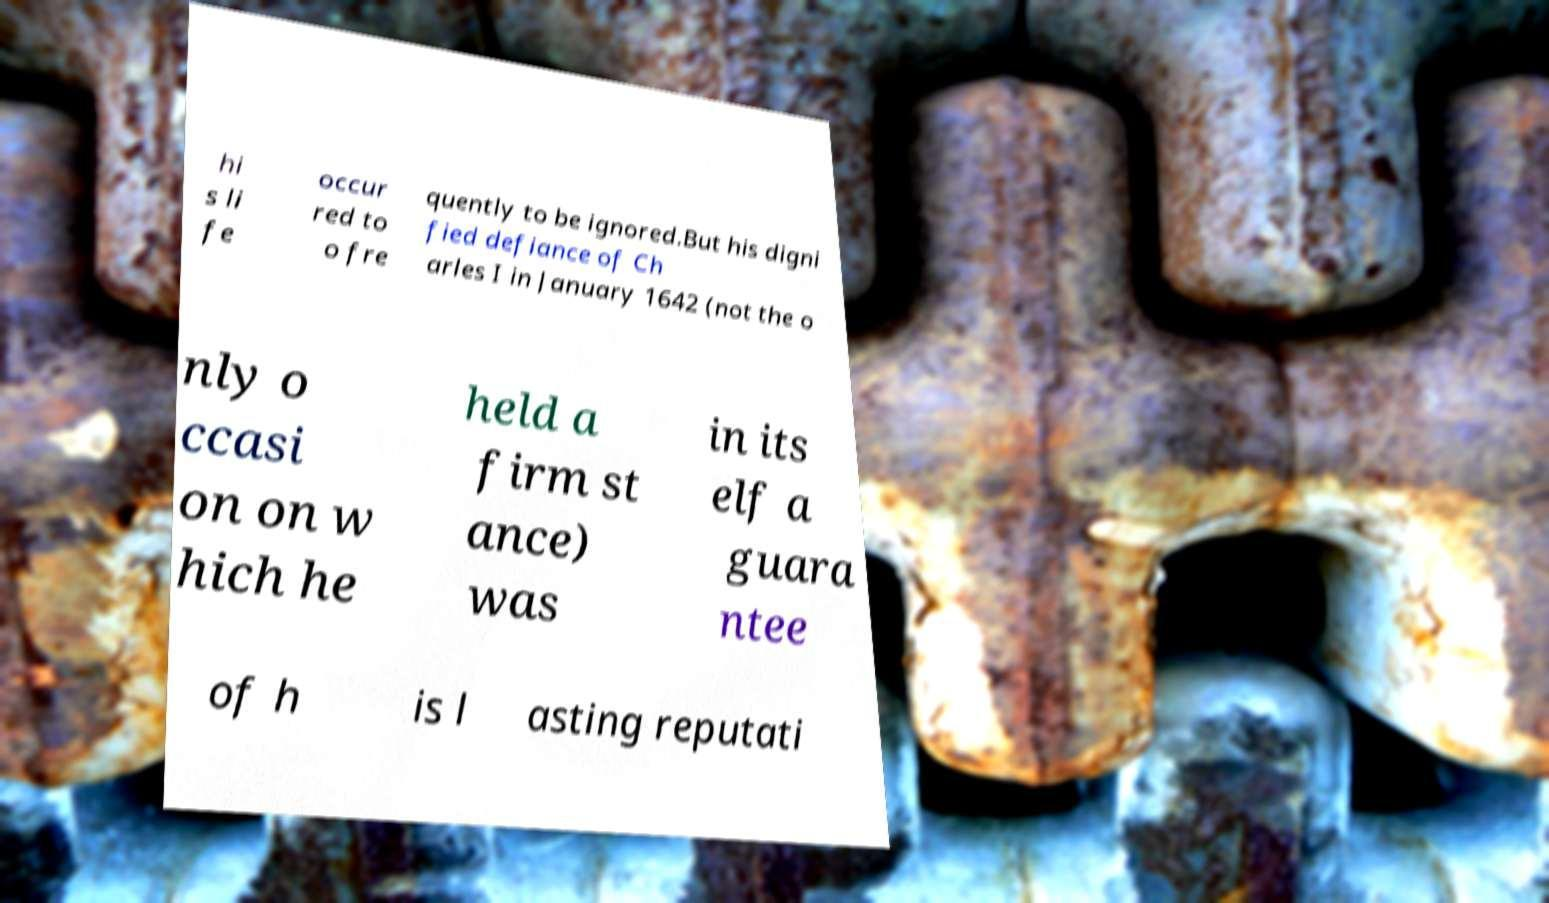Please identify and transcribe the text found in this image. hi s li fe occur red to o fre quently to be ignored.But his digni fied defiance of Ch arles I in January 1642 (not the o nly o ccasi on on w hich he held a firm st ance) was in its elf a guara ntee of h is l asting reputati 